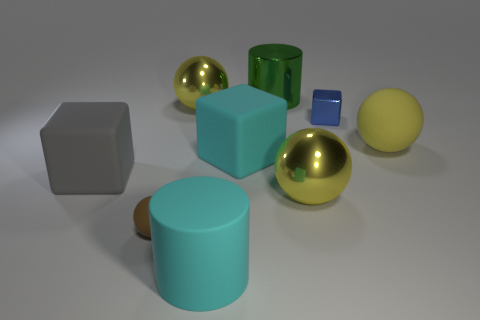Subtract all green blocks. How many yellow balls are left? 3 Add 1 cyan blocks. How many objects exist? 10 Subtract all cubes. How many objects are left? 6 Subtract all small blocks. Subtract all tiny gray rubber cylinders. How many objects are left? 8 Add 3 balls. How many balls are left? 7 Add 4 big gray objects. How many big gray objects exist? 5 Subtract 1 brown balls. How many objects are left? 8 